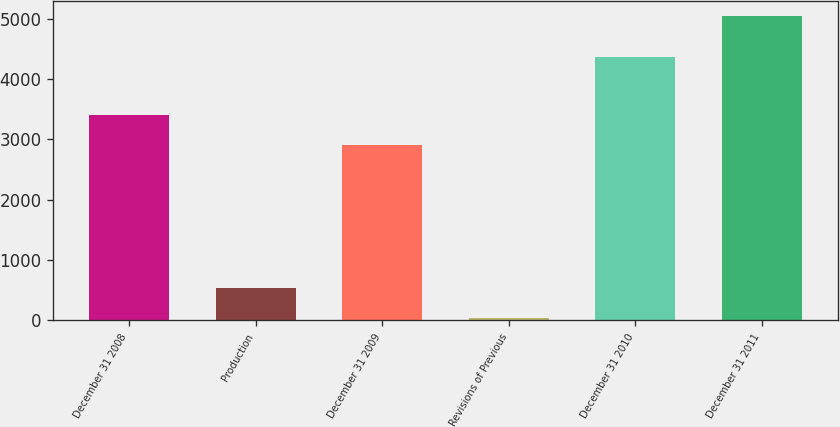Convert chart to OTSL. <chart><loc_0><loc_0><loc_500><loc_500><bar_chart><fcel>December 31 2008<fcel>Production<fcel>December 31 2009<fcel>Revisions of Previous<fcel>December 31 2010<fcel>December 31 2011<nl><fcel>3404.5<fcel>538.5<fcel>2904<fcel>38<fcel>4361<fcel>5043<nl></chart> 